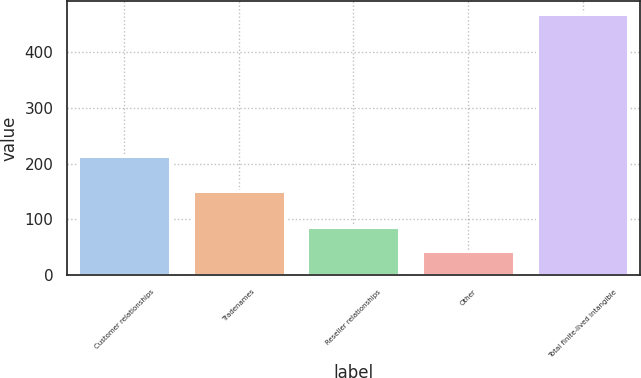Convert chart to OTSL. <chart><loc_0><loc_0><loc_500><loc_500><bar_chart><fcel>Customer relationships<fcel>Tradenames<fcel>Reseller relationships<fcel>Other<fcel>Total finite-lived intangible<nl><fcel>214<fcel>151<fcel>86.4<fcel>44<fcel>468<nl></chart> 